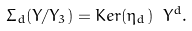<formula> <loc_0><loc_0><loc_500><loc_500>\Sigma _ { d } ( Y / Y _ { 3 } ) = K e r ( \eta _ { d } ) \ Y ^ { d } .</formula> 